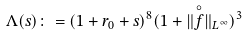Convert formula to latex. <formula><loc_0><loc_0><loc_500><loc_500>\Lambda ( s ) \colon = ( 1 + r _ { 0 } + s ) ^ { 8 } ( 1 + \| \overset { \circ } { f } \| _ { L ^ { \infty } } ) ^ { 3 }</formula> 